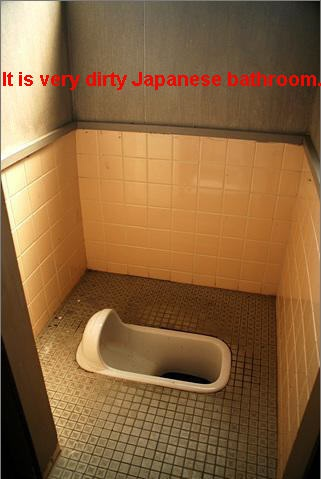Describe the objects in this image and their specific colors. I can see a toilet in gray, maroon, olive, and tan tones in this image. 